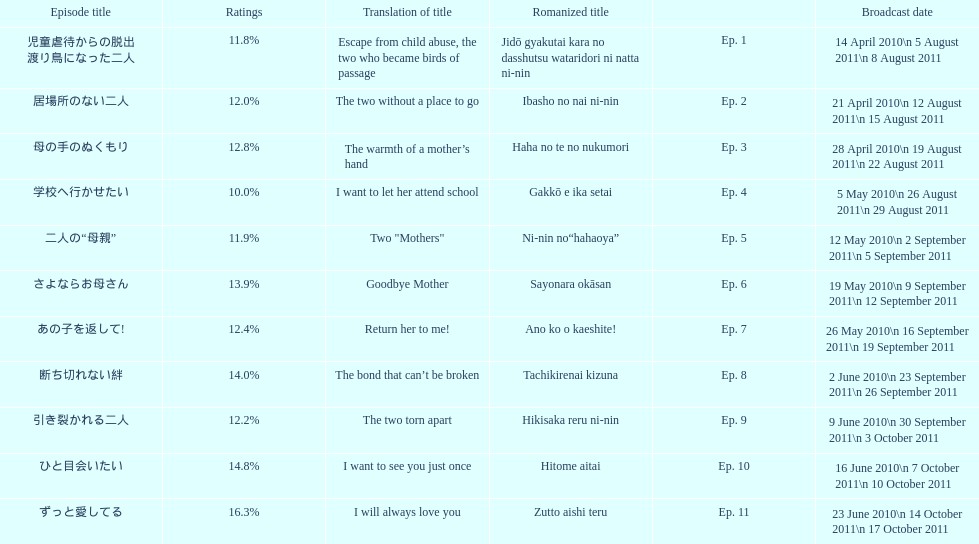What were all the episode titles for the show mother? 児童虐待からの脱出 渡り鳥になった二人, 居場所のない二人, 母の手のぬくもり, 学校へ行かせたい, 二人の“母親”, さよならお母さん, あの子を返して!, 断ち切れない絆, 引き裂かれる二人, ひと目会いたい, ずっと愛してる. What were all the translated episode titles for the show mother? Escape from child abuse, the two who became birds of passage, The two without a place to go, The warmth of a mother’s hand, I want to let her attend school, Two "Mothers", Goodbye Mother, Return her to me!, The bond that can’t be broken, The two torn apart, I want to see you just once, I will always love you. Which episode was translated to i want to let her attend school? Ep. 4. 